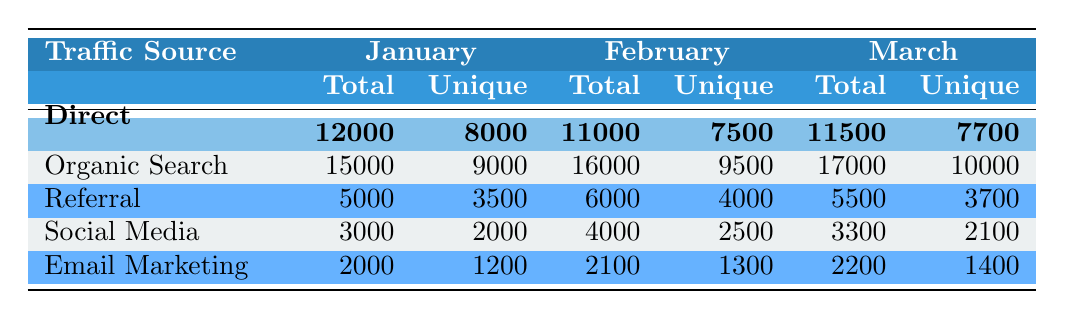What was the total number of unique visitors from Organic Search in March? From the table, the total number of unique visitors from Organic Search in March is listed as 10000.
Answer: 10000 What is the total number of visits from Social Media for all three months? By summing the total visits from Social Media for January (3000), February (4000), and March (3300), we get 3000 + 4000 + 3300 = 10300.
Answer: 10300 Did the number of Unique Visitors from Email Marketing increase from January to March? In January, the number of Unique Visitors from Email Marketing was 1200, and in March, it was 1400. Since 1400 is greater than 1200, there was an increase.
Answer: Yes Which traffic source had the highest total visits in February? In February, the traffic source with the highest total visits is Organic Search with 16000 visits, compared to the others.
Answer: Organic Search Calculate the average total visits from Direct traffic over the three months. To find the average total visits from Direct traffic, we sum the total visits: January (12000) + February (11000) + March (11500) = 34500, and then divide by 3 (the number of months): 34500 / 3 = 11500.
Answer: 11500 How many total visits did Referral sources receive in January compared to March? In January, Referral sources had 5000 total visits, and in March, they had 5500. To compare: March (5500) is greater than January (5000).
Answer: March had more visits Was the number of unique visitors from Social Media greater in February than in January? In February, the unique visitors from Social Media were 2500, while in January, they were 2000. Since 2500 is greater than 2000, the answer is yes.
Answer: Yes What was the total number of unique visitors across all sources in January? To find the total unique visitors in January, we sum the unique visitors from each source: Direct (8000) + Organic Search (9000) + Referral (3500) + Social Media (2000) + Email Marketing (1200) = 22700.
Answer: 22700 Which month saw the lowest total visits overall? To find the month with the lowest total visits, we calculate the total visits for each month. For January: 12000 + 15000 + 5000 + 3000 + 2000 = 35000; February: 11000 + 16000 + 6000 + 4000 + 2100 = 45000; March: 11500 + 17000 + 5500 + 3300 + 2200 = 40900. Since January has the lowest total visits, it is the correct answer.
Answer: January 